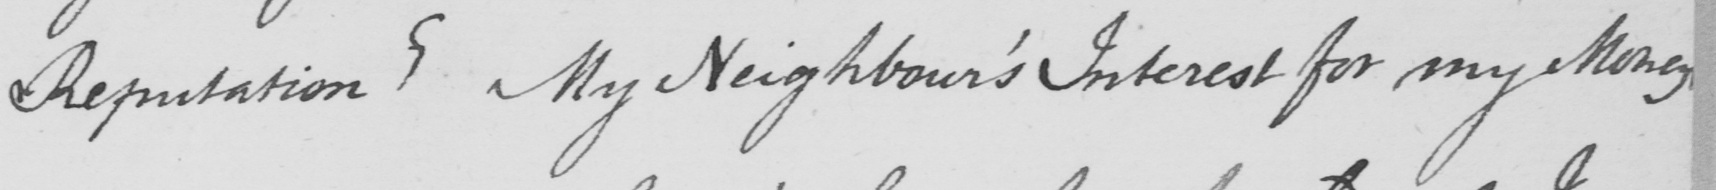Transcribe the text shown in this historical manuscript line. Reputation ?  My Neighbour ' s Interest for my Money 